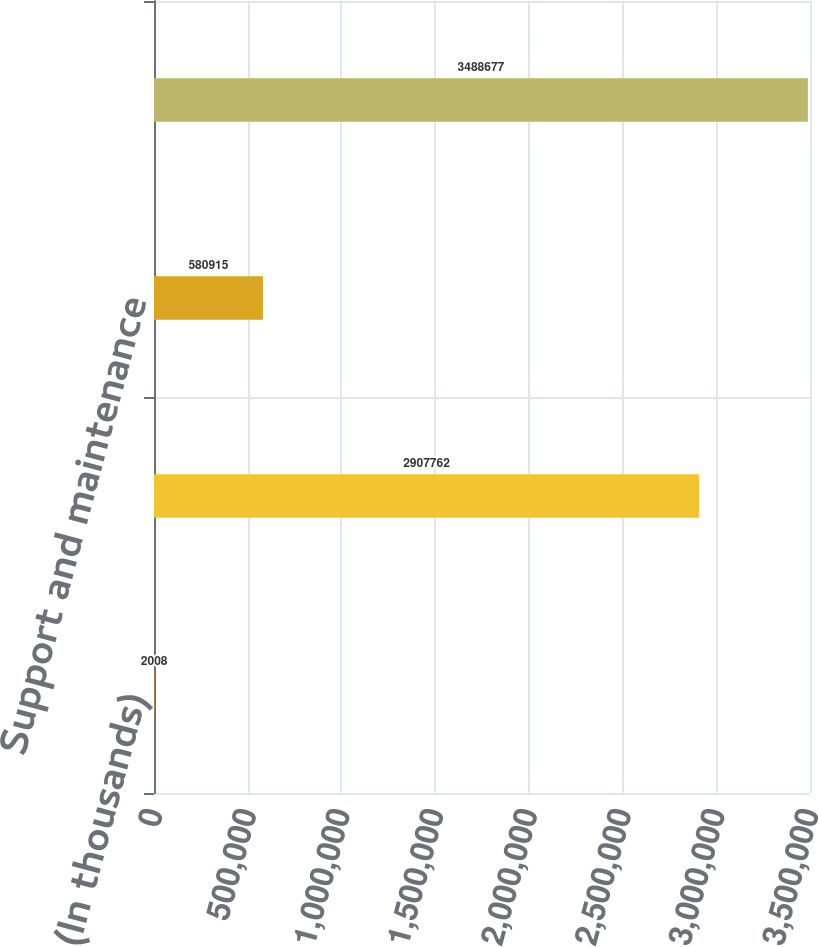Convert chart. <chart><loc_0><loc_0><loc_500><loc_500><bar_chart><fcel>(In thousands)<fcel>Contract backlog<fcel>Support and maintenance<fcel>Total backlog<nl><fcel>2008<fcel>2.90776e+06<fcel>580915<fcel>3.48868e+06<nl></chart> 